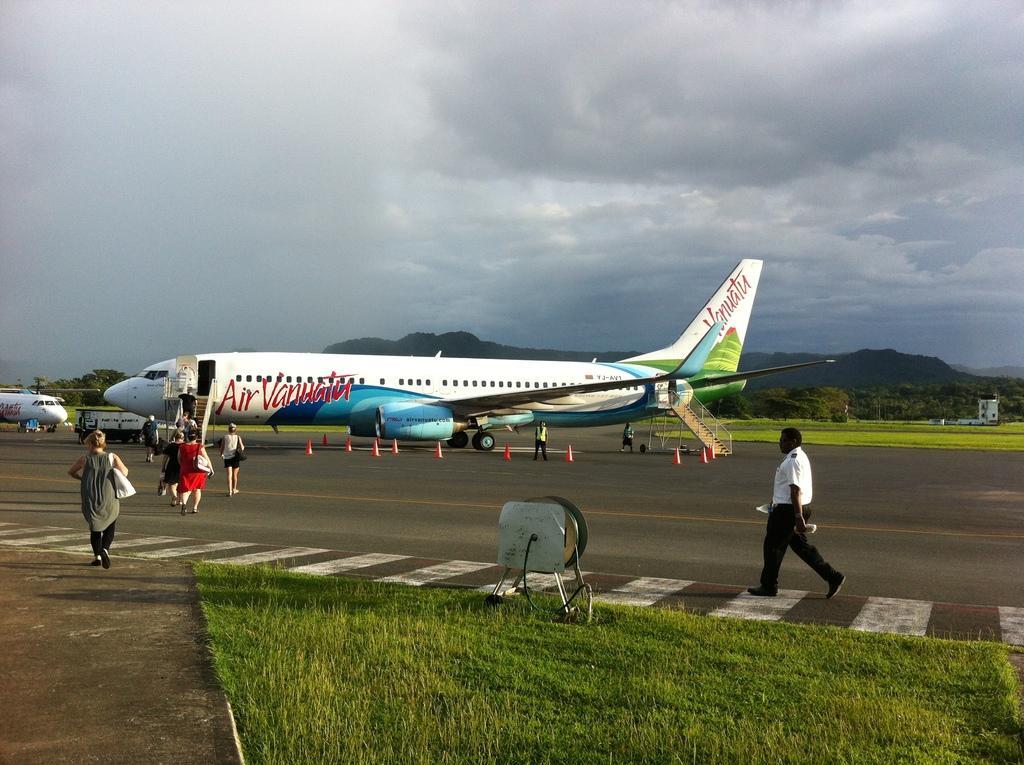In one or two sentences, can you explain what this image depicts? In this picture, we see an airplane in white color is on the runway. Here, we see people are walking towards the airplane, which is on the runway. Beside that, we see stoppers in red color. On the right side, the man in the white shirt is walking. Beside him, we see grass and an iron thing. On the left side, we see an airplane is on the runway. There are trees in the background. At the top of the picture, we see the sky. 